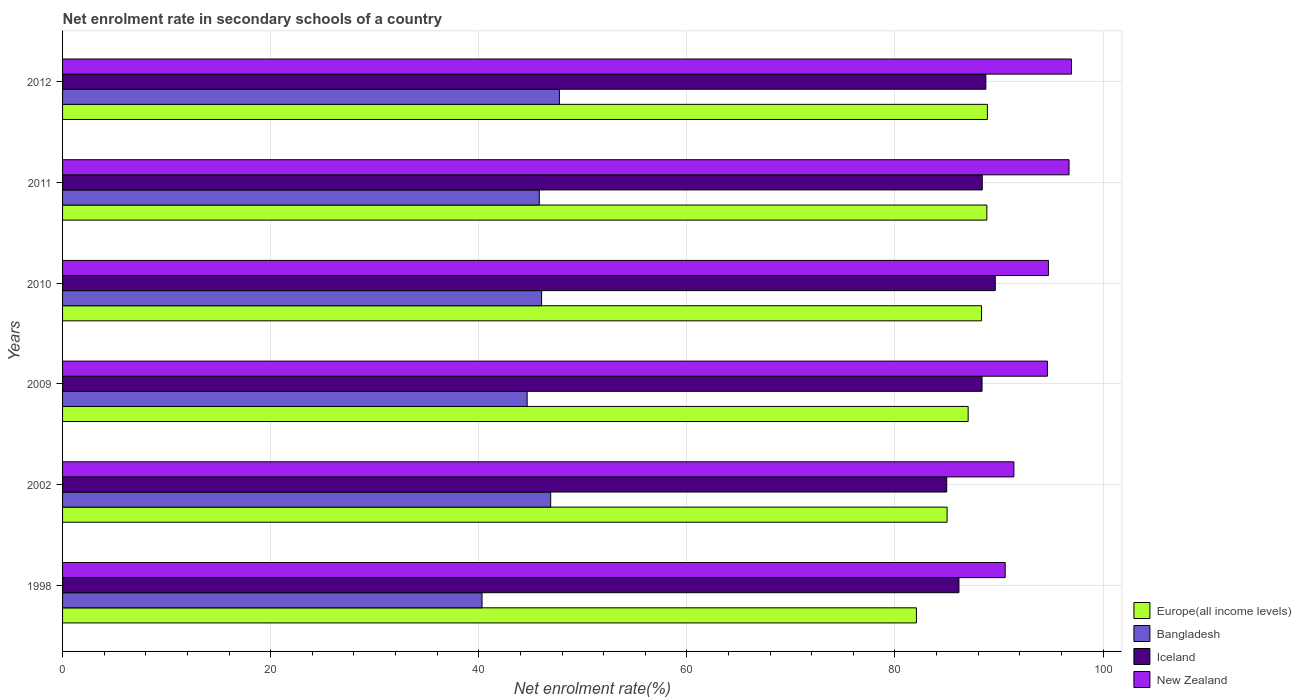How many different coloured bars are there?
Ensure brevity in your answer.  4. Are the number of bars per tick equal to the number of legend labels?
Keep it short and to the point. Yes. How many bars are there on the 2nd tick from the top?
Keep it short and to the point. 4. How many bars are there on the 5th tick from the bottom?
Offer a very short reply. 4. What is the label of the 5th group of bars from the top?
Your response must be concise. 2002. What is the net enrolment rate in secondary schools in Europe(all income levels) in 2010?
Offer a terse response. 88.32. Across all years, what is the maximum net enrolment rate in secondary schools in Bangladesh?
Give a very brief answer. 47.75. Across all years, what is the minimum net enrolment rate in secondary schools in Europe(all income levels)?
Give a very brief answer. 82.06. In which year was the net enrolment rate in secondary schools in Bangladesh maximum?
Your answer should be compact. 2012. In which year was the net enrolment rate in secondary schools in Bangladesh minimum?
Make the answer very short. 1998. What is the total net enrolment rate in secondary schools in New Zealand in the graph?
Make the answer very short. 565.1. What is the difference between the net enrolment rate in secondary schools in Bangladesh in 2009 and that in 2012?
Make the answer very short. -3.1. What is the difference between the net enrolment rate in secondary schools in New Zealand in 2011 and the net enrolment rate in secondary schools in Europe(all income levels) in 1998?
Give a very brief answer. 14.67. What is the average net enrolment rate in secondary schools in Iceland per year?
Your answer should be very brief. 87.71. In the year 2011, what is the difference between the net enrolment rate in secondary schools in New Zealand and net enrolment rate in secondary schools in Europe(all income levels)?
Keep it short and to the point. 7.9. In how many years, is the net enrolment rate in secondary schools in Iceland greater than 84 %?
Offer a very short reply. 6. What is the ratio of the net enrolment rate in secondary schools in Bangladesh in 2009 to that in 2010?
Make the answer very short. 0.97. Is the net enrolment rate in secondary schools in New Zealand in 1998 less than that in 2009?
Offer a very short reply. Yes. What is the difference between the highest and the second highest net enrolment rate in secondary schools in New Zealand?
Offer a terse response. 0.23. What is the difference between the highest and the lowest net enrolment rate in secondary schools in Europe(all income levels)?
Your response must be concise. 6.82. Is the sum of the net enrolment rate in secondary schools in Europe(all income levels) in 2009 and 2012 greater than the maximum net enrolment rate in secondary schools in Iceland across all years?
Offer a very short reply. Yes. Is it the case that in every year, the sum of the net enrolment rate in secondary schools in New Zealand and net enrolment rate in secondary schools in Europe(all income levels) is greater than the sum of net enrolment rate in secondary schools in Bangladesh and net enrolment rate in secondary schools in Iceland?
Your response must be concise. No. What does the 3rd bar from the top in 2011 represents?
Keep it short and to the point. Bangladesh. What does the 1st bar from the bottom in 2010 represents?
Provide a succinct answer. Europe(all income levels). How many bars are there?
Make the answer very short. 24. What is the difference between two consecutive major ticks on the X-axis?
Offer a terse response. 20. Does the graph contain any zero values?
Ensure brevity in your answer.  No. Does the graph contain grids?
Your response must be concise. Yes. How many legend labels are there?
Offer a terse response. 4. What is the title of the graph?
Your response must be concise. Net enrolment rate in secondary schools of a country. Does "Slovak Republic" appear as one of the legend labels in the graph?
Give a very brief answer. No. What is the label or title of the X-axis?
Your answer should be very brief. Net enrolment rate(%). What is the label or title of the Y-axis?
Your answer should be very brief. Years. What is the Net enrolment rate(%) of Europe(all income levels) in 1998?
Your answer should be compact. 82.06. What is the Net enrolment rate(%) of Bangladesh in 1998?
Your answer should be very brief. 40.31. What is the Net enrolment rate(%) of Iceland in 1998?
Offer a very short reply. 86.15. What is the Net enrolment rate(%) of New Zealand in 1998?
Offer a terse response. 90.59. What is the Net enrolment rate(%) in Europe(all income levels) in 2002?
Your response must be concise. 85.01. What is the Net enrolment rate(%) in Bangladesh in 2002?
Your answer should be very brief. 46.91. What is the Net enrolment rate(%) of Iceland in 2002?
Offer a terse response. 84.97. What is the Net enrolment rate(%) of New Zealand in 2002?
Your answer should be very brief. 91.43. What is the Net enrolment rate(%) in Europe(all income levels) in 2009?
Your answer should be very brief. 87.03. What is the Net enrolment rate(%) of Bangladesh in 2009?
Ensure brevity in your answer.  44.65. What is the Net enrolment rate(%) in Iceland in 2009?
Offer a terse response. 88.37. What is the Net enrolment rate(%) in New Zealand in 2009?
Keep it short and to the point. 94.65. What is the Net enrolment rate(%) of Europe(all income levels) in 2010?
Your response must be concise. 88.32. What is the Net enrolment rate(%) in Bangladesh in 2010?
Offer a very short reply. 46.04. What is the Net enrolment rate(%) of Iceland in 2010?
Your answer should be very brief. 89.64. What is the Net enrolment rate(%) in New Zealand in 2010?
Offer a very short reply. 94.75. What is the Net enrolment rate(%) in Europe(all income levels) in 2011?
Ensure brevity in your answer.  88.83. What is the Net enrolment rate(%) of Bangladesh in 2011?
Offer a terse response. 45.82. What is the Net enrolment rate(%) of Iceland in 2011?
Provide a short and direct response. 88.39. What is the Net enrolment rate(%) of New Zealand in 2011?
Keep it short and to the point. 96.73. What is the Net enrolment rate(%) in Europe(all income levels) in 2012?
Your response must be concise. 88.88. What is the Net enrolment rate(%) in Bangladesh in 2012?
Give a very brief answer. 47.75. What is the Net enrolment rate(%) of Iceland in 2012?
Your answer should be very brief. 88.73. What is the Net enrolment rate(%) of New Zealand in 2012?
Give a very brief answer. 96.96. Across all years, what is the maximum Net enrolment rate(%) in Europe(all income levels)?
Give a very brief answer. 88.88. Across all years, what is the maximum Net enrolment rate(%) of Bangladesh?
Make the answer very short. 47.75. Across all years, what is the maximum Net enrolment rate(%) of Iceland?
Offer a very short reply. 89.64. Across all years, what is the maximum Net enrolment rate(%) in New Zealand?
Your answer should be compact. 96.96. Across all years, what is the minimum Net enrolment rate(%) of Europe(all income levels)?
Make the answer very short. 82.06. Across all years, what is the minimum Net enrolment rate(%) in Bangladesh?
Your response must be concise. 40.31. Across all years, what is the minimum Net enrolment rate(%) of Iceland?
Offer a terse response. 84.97. Across all years, what is the minimum Net enrolment rate(%) in New Zealand?
Provide a short and direct response. 90.59. What is the total Net enrolment rate(%) in Europe(all income levels) in the graph?
Provide a short and direct response. 520.12. What is the total Net enrolment rate(%) in Bangladesh in the graph?
Make the answer very short. 271.47. What is the total Net enrolment rate(%) of Iceland in the graph?
Your answer should be very brief. 526.24. What is the total Net enrolment rate(%) of New Zealand in the graph?
Ensure brevity in your answer.  565.1. What is the difference between the Net enrolment rate(%) of Europe(all income levels) in 1998 and that in 2002?
Your response must be concise. -2.95. What is the difference between the Net enrolment rate(%) of Bangladesh in 1998 and that in 2002?
Make the answer very short. -6.6. What is the difference between the Net enrolment rate(%) in Iceland in 1998 and that in 2002?
Offer a very short reply. 1.17. What is the difference between the Net enrolment rate(%) of New Zealand in 1998 and that in 2002?
Offer a very short reply. -0.83. What is the difference between the Net enrolment rate(%) in Europe(all income levels) in 1998 and that in 2009?
Your response must be concise. -4.97. What is the difference between the Net enrolment rate(%) in Bangladesh in 1998 and that in 2009?
Keep it short and to the point. -4.34. What is the difference between the Net enrolment rate(%) in Iceland in 1998 and that in 2009?
Your response must be concise. -2.22. What is the difference between the Net enrolment rate(%) of New Zealand in 1998 and that in 2009?
Make the answer very short. -4.06. What is the difference between the Net enrolment rate(%) of Europe(all income levels) in 1998 and that in 2010?
Ensure brevity in your answer.  -6.26. What is the difference between the Net enrolment rate(%) in Bangladesh in 1998 and that in 2010?
Keep it short and to the point. -5.72. What is the difference between the Net enrolment rate(%) of Iceland in 1998 and that in 2010?
Keep it short and to the point. -3.49. What is the difference between the Net enrolment rate(%) in New Zealand in 1998 and that in 2010?
Offer a very short reply. -4.15. What is the difference between the Net enrolment rate(%) in Europe(all income levels) in 1998 and that in 2011?
Provide a succinct answer. -6.77. What is the difference between the Net enrolment rate(%) of Bangladesh in 1998 and that in 2011?
Ensure brevity in your answer.  -5.5. What is the difference between the Net enrolment rate(%) in Iceland in 1998 and that in 2011?
Keep it short and to the point. -2.24. What is the difference between the Net enrolment rate(%) of New Zealand in 1998 and that in 2011?
Provide a succinct answer. -6.14. What is the difference between the Net enrolment rate(%) in Europe(all income levels) in 1998 and that in 2012?
Offer a very short reply. -6.82. What is the difference between the Net enrolment rate(%) of Bangladesh in 1998 and that in 2012?
Your answer should be very brief. -7.44. What is the difference between the Net enrolment rate(%) of Iceland in 1998 and that in 2012?
Offer a very short reply. -2.59. What is the difference between the Net enrolment rate(%) in New Zealand in 1998 and that in 2012?
Keep it short and to the point. -6.37. What is the difference between the Net enrolment rate(%) of Europe(all income levels) in 2002 and that in 2009?
Offer a terse response. -2.02. What is the difference between the Net enrolment rate(%) of Bangladesh in 2002 and that in 2009?
Provide a short and direct response. 2.26. What is the difference between the Net enrolment rate(%) in Iceland in 2002 and that in 2009?
Your answer should be very brief. -3.39. What is the difference between the Net enrolment rate(%) of New Zealand in 2002 and that in 2009?
Offer a terse response. -3.22. What is the difference between the Net enrolment rate(%) in Europe(all income levels) in 2002 and that in 2010?
Provide a short and direct response. -3.31. What is the difference between the Net enrolment rate(%) of Bangladesh in 2002 and that in 2010?
Provide a short and direct response. 0.87. What is the difference between the Net enrolment rate(%) in Iceland in 2002 and that in 2010?
Make the answer very short. -4.67. What is the difference between the Net enrolment rate(%) of New Zealand in 2002 and that in 2010?
Make the answer very short. -3.32. What is the difference between the Net enrolment rate(%) of Europe(all income levels) in 2002 and that in 2011?
Give a very brief answer. -3.82. What is the difference between the Net enrolment rate(%) in Bangladesh in 2002 and that in 2011?
Your response must be concise. 1.09. What is the difference between the Net enrolment rate(%) in Iceland in 2002 and that in 2011?
Your answer should be compact. -3.41. What is the difference between the Net enrolment rate(%) of New Zealand in 2002 and that in 2011?
Provide a succinct answer. -5.3. What is the difference between the Net enrolment rate(%) in Europe(all income levels) in 2002 and that in 2012?
Your answer should be very brief. -3.87. What is the difference between the Net enrolment rate(%) in Bangladesh in 2002 and that in 2012?
Give a very brief answer. -0.84. What is the difference between the Net enrolment rate(%) of Iceland in 2002 and that in 2012?
Make the answer very short. -3.76. What is the difference between the Net enrolment rate(%) in New Zealand in 2002 and that in 2012?
Your answer should be compact. -5.53. What is the difference between the Net enrolment rate(%) of Europe(all income levels) in 2009 and that in 2010?
Offer a very short reply. -1.29. What is the difference between the Net enrolment rate(%) in Bangladesh in 2009 and that in 2010?
Ensure brevity in your answer.  -1.39. What is the difference between the Net enrolment rate(%) in Iceland in 2009 and that in 2010?
Provide a succinct answer. -1.27. What is the difference between the Net enrolment rate(%) in New Zealand in 2009 and that in 2010?
Provide a succinct answer. -0.1. What is the difference between the Net enrolment rate(%) of Europe(all income levels) in 2009 and that in 2011?
Ensure brevity in your answer.  -1.8. What is the difference between the Net enrolment rate(%) in Bangladesh in 2009 and that in 2011?
Give a very brief answer. -1.17. What is the difference between the Net enrolment rate(%) in Iceland in 2009 and that in 2011?
Your answer should be very brief. -0.02. What is the difference between the Net enrolment rate(%) of New Zealand in 2009 and that in 2011?
Keep it short and to the point. -2.08. What is the difference between the Net enrolment rate(%) in Europe(all income levels) in 2009 and that in 2012?
Keep it short and to the point. -1.85. What is the difference between the Net enrolment rate(%) in Bangladesh in 2009 and that in 2012?
Your response must be concise. -3.1. What is the difference between the Net enrolment rate(%) in Iceland in 2009 and that in 2012?
Offer a very short reply. -0.36. What is the difference between the Net enrolment rate(%) in New Zealand in 2009 and that in 2012?
Your response must be concise. -2.31. What is the difference between the Net enrolment rate(%) in Europe(all income levels) in 2010 and that in 2011?
Ensure brevity in your answer.  -0.51. What is the difference between the Net enrolment rate(%) of Bangladesh in 2010 and that in 2011?
Provide a succinct answer. 0.22. What is the difference between the Net enrolment rate(%) in Iceland in 2010 and that in 2011?
Make the answer very short. 1.25. What is the difference between the Net enrolment rate(%) in New Zealand in 2010 and that in 2011?
Keep it short and to the point. -1.98. What is the difference between the Net enrolment rate(%) in Europe(all income levels) in 2010 and that in 2012?
Provide a succinct answer. -0.56. What is the difference between the Net enrolment rate(%) of Bangladesh in 2010 and that in 2012?
Your answer should be compact. -1.71. What is the difference between the Net enrolment rate(%) of Iceland in 2010 and that in 2012?
Your answer should be very brief. 0.91. What is the difference between the Net enrolment rate(%) of New Zealand in 2010 and that in 2012?
Give a very brief answer. -2.21. What is the difference between the Net enrolment rate(%) of Europe(all income levels) in 2011 and that in 2012?
Your answer should be very brief. -0.05. What is the difference between the Net enrolment rate(%) in Bangladesh in 2011 and that in 2012?
Offer a terse response. -1.93. What is the difference between the Net enrolment rate(%) of Iceland in 2011 and that in 2012?
Make the answer very short. -0.35. What is the difference between the Net enrolment rate(%) of New Zealand in 2011 and that in 2012?
Give a very brief answer. -0.23. What is the difference between the Net enrolment rate(%) of Europe(all income levels) in 1998 and the Net enrolment rate(%) of Bangladesh in 2002?
Ensure brevity in your answer.  35.15. What is the difference between the Net enrolment rate(%) in Europe(all income levels) in 1998 and the Net enrolment rate(%) in Iceland in 2002?
Ensure brevity in your answer.  -2.91. What is the difference between the Net enrolment rate(%) in Europe(all income levels) in 1998 and the Net enrolment rate(%) in New Zealand in 2002?
Ensure brevity in your answer.  -9.37. What is the difference between the Net enrolment rate(%) of Bangladesh in 1998 and the Net enrolment rate(%) of Iceland in 2002?
Your answer should be compact. -44.66. What is the difference between the Net enrolment rate(%) in Bangladesh in 1998 and the Net enrolment rate(%) in New Zealand in 2002?
Your answer should be compact. -51.11. What is the difference between the Net enrolment rate(%) of Iceland in 1998 and the Net enrolment rate(%) of New Zealand in 2002?
Give a very brief answer. -5.28. What is the difference between the Net enrolment rate(%) of Europe(all income levels) in 1998 and the Net enrolment rate(%) of Bangladesh in 2009?
Keep it short and to the point. 37.41. What is the difference between the Net enrolment rate(%) in Europe(all income levels) in 1998 and the Net enrolment rate(%) in Iceland in 2009?
Your answer should be very brief. -6.31. What is the difference between the Net enrolment rate(%) of Europe(all income levels) in 1998 and the Net enrolment rate(%) of New Zealand in 2009?
Provide a succinct answer. -12.59. What is the difference between the Net enrolment rate(%) in Bangladesh in 1998 and the Net enrolment rate(%) in Iceland in 2009?
Offer a terse response. -48.05. What is the difference between the Net enrolment rate(%) in Bangladesh in 1998 and the Net enrolment rate(%) in New Zealand in 2009?
Provide a succinct answer. -54.34. What is the difference between the Net enrolment rate(%) in Iceland in 1998 and the Net enrolment rate(%) in New Zealand in 2009?
Give a very brief answer. -8.5. What is the difference between the Net enrolment rate(%) of Europe(all income levels) in 1998 and the Net enrolment rate(%) of Bangladesh in 2010?
Your answer should be compact. 36.02. What is the difference between the Net enrolment rate(%) in Europe(all income levels) in 1998 and the Net enrolment rate(%) in Iceland in 2010?
Give a very brief answer. -7.58. What is the difference between the Net enrolment rate(%) in Europe(all income levels) in 1998 and the Net enrolment rate(%) in New Zealand in 2010?
Offer a very short reply. -12.69. What is the difference between the Net enrolment rate(%) in Bangladesh in 1998 and the Net enrolment rate(%) in Iceland in 2010?
Make the answer very short. -49.33. What is the difference between the Net enrolment rate(%) of Bangladesh in 1998 and the Net enrolment rate(%) of New Zealand in 2010?
Your answer should be compact. -54.43. What is the difference between the Net enrolment rate(%) in Iceland in 1998 and the Net enrolment rate(%) in New Zealand in 2010?
Provide a short and direct response. -8.6. What is the difference between the Net enrolment rate(%) of Europe(all income levels) in 1998 and the Net enrolment rate(%) of Bangladesh in 2011?
Ensure brevity in your answer.  36.24. What is the difference between the Net enrolment rate(%) of Europe(all income levels) in 1998 and the Net enrolment rate(%) of Iceland in 2011?
Offer a very short reply. -6.33. What is the difference between the Net enrolment rate(%) in Europe(all income levels) in 1998 and the Net enrolment rate(%) in New Zealand in 2011?
Ensure brevity in your answer.  -14.67. What is the difference between the Net enrolment rate(%) of Bangladesh in 1998 and the Net enrolment rate(%) of Iceland in 2011?
Give a very brief answer. -48.07. What is the difference between the Net enrolment rate(%) in Bangladesh in 1998 and the Net enrolment rate(%) in New Zealand in 2011?
Provide a succinct answer. -56.42. What is the difference between the Net enrolment rate(%) of Iceland in 1998 and the Net enrolment rate(%) of New Zealand in 2011?
Offer a terse response. -10.58. What is the difference between the Net enrolment rate(%) of Europe(all income levels) in 1998 and the Net enrolment rate(%) of Bangladesh in 2012?
Offer a terse response. 34.31. What is the difference between the Net enrolment rate(%) in Europe(all income levels) in 1998 and the Net enrolment rate(%) in Iceland in 2012?
Make the answer very short. -6.67. What is the difference between the Net enrolment rate(%) in Europe(all income levels) in 1998 and the Net enrolment rate(%) in New Zealand in 2012?
Offer a very short reply. -14.9. What is the difference between the Net enrolment rate(%) in Bangladesh in 1998 and the Net enrolment rate(%) in Iceland in 2012?
Ensure brevity in your answer.  -48.42. What is the difference between the Net enrolment rate(%) in Bangladesh in 1998 and the Net enrolment rate(%) in New Zealand in 2012?
Provide a succinct answer. -56.65. What is the difference between the Net enrolment rate(%) of Iceland in 1998 and the Net enrolment rate(%) of New Zealand in 2012?
Offer a very short reply. -10.81. What is the difference between the Net enrolment rate(%) in Europe(all income levels) in 2002 and the Net enrolment rate(%) in Bangladesh in 2009?
Offer a terse response. 40.36. What is the difference between the Net enrolment rate(%) of Europe(all income levels) in 2002 and the Net enrolment rate(%) of Iceland in 2009?
Your response must be concise. -3.36. What is the difference between the Net enrolment rate(%) in Europe(all income levels) in 2002 and the Net enrolment rate(%) in New Zealand in 2009?
Offer a very short reply. -9.64. What is the difference between the Net enrolment rate(%) in Bangladesh in 2002 and the Net enrolment rate(%) in Iceland in 2009?
Provide a short and direct response. -41.46. What is the difference between the Net enrolment rate(%) of Bangladesh in 2002 and the Net enrolment rate(%) of New Zealand in 2009?
Your response must be concise. -47.74. What is the difference between the Net enrolment rate(%) in Iceland in 2002 and the Net enrolment rate(%) in New Zealand in 2009?
Offer a very short reply. -9.68. What is the difference between the Net enrolment rate(%) in Europe(all income levels) in 2002 and the Net enrolment rate(%) in Bangladesh in 2010?
Your answer should be very brief. 38.97. What is the difference between the Net enrolment rate(%) in Europe(all income levels) in 2002 and the Net enrolment rate(%) in Iceland in 2010?
Offer a very short reply. -4.63. What is the difference between the Net enrolment rate(%) in Europe(all income levels) in 2002 and the Net enrolment rate(%) in New Zealand in 2010?
Ensure brevity in your answer.  -9.74. What is the difference between the Net enrolment rate(%) of Bangladesh in 2002 and the Net enrolment rate(%) of Iceland in 2010?
Your response must be concise. -42.73. What is the difference between the Net enrolment rate(%) of Bangladesh in 2002 and the Net enrolment rate(%) of New Zealand in 2010?
Your response must be concise. -47.84. What is the difference between the Net enrolment rate(%) of Iceland in 2002 and the Net enrolment rate(%) of New Zealand in 2010?
Give a very brief answer. -9.77. What is the difference between the Net enrolment rate(%) of Europe(all income levels) in 2002 and the Net enrolment rate(%) of Bangladesh in 2011?
Provide a succinct answer. 39.19. What is the difference between the Net enrolment rate(%) in Europe(all income levels) in 2002 and the Net enrolment rate(%) in Iceland in 2011?
Give a very brief answer. -3.38. What is the difference between the Net enrolment rate(%) in Europe(all income levels) in 2002 and the Net enrolment rate(%) in New Zealand in 2011?
Your response must be concise. -11.72. What is the difference between the Net enrolment rate(%) of Bangladesh in 2002 and the Net enrolment rate(%) of Iceland in 2011?
Make the answer very short. -41.48. What is the difference between the Net enrolment rate(%) of Bangladesh in 2002 and the Net enrolment rate(%) of New Zealand in 2011?
Provide a succinct answer. -49.82. What is the difference between the Net enrolment rate(%) in Iceland in 2002 and the Net enrolment rate(%) in New Zealand in 2011?
Give a very brief answer. -11.76. What is the difference between the Net enrolment rate(%) in Europe(all income levels) in 2002 and the Net enrolment rate(%) in Bangladesh in 2012?
Ensure brevity in your answer.  37.26. What is the difference between the Net enrolment rate(%) in Europe(all income levels) in 2002 and the Net enrolment rate(%) in Iceland in 2012?
Your answer should be very brief. -3.72. What is the difference between the Net enrolment rate(%) in Europe(all income levels) in 2002 and the Net enrolment rate(%) in New Zealand in 2012?
Your answer should be very brief. -11.95. What is the difference between the Net enrolment rate(%) in Bangladesh in 2002 and the Net enrolment rate(%) in Iceland in 2012?
Provide a succinct answer. -41.82. What is the difference between the Net enrolment rate(%) of Bangladesh in 2002 and the Net enrolment rate(%) of New Zealand in 2012?
Ensure brevity in your answer.  -50.05. What is the difference between the Net enrolment rate(%) of Iceland in 2002 and the Net enrolment rate(%) of New Zealand in 2012?
Offer a very short reply. -11.99. What is the difference between the Net enrolment rate(%) in Europe(all income levels) in 2009 and the Net enrolment rate(%) in Bangladesh in 2010?
Make the answer very short. 40.99. What is the difference between the Net enrolment rate(%) in Europe(all income levels) in 2009 and the Net enrolment rate(%) in Iceland in 2010?
Your answer should be compact. -2.61. What is the difference between the Net enrolment rate(%) in Europe(all income levels) in 2009 and the Net enrolment rate(%) in New Zealand in 2010?
Provide a succinct answer. -7.71. What is the difference between the Net enrolment rate(%) in Bangladesh in 2009 and the Net enrolment rate(%) in Iceland in 2010?
Offer a very short reply. -44.99. What is the difference between the Net enrolment rate(%) in Bangladesh in 2009 and the Net enrolment rate(%) in New Zealand in 2010?
Provide a short and direct response. -50.1. What is the difference between the Net enrolment rate(%) of Iceland in 2009 and the Net enrolment rate(%) of New Zealand in 2010?
Ensure brevity in your answer.  -6.38. What is the difference between the Net enrolment rate(%) in Europe(all income levels) in 2009 and the Net enrolment rate(%) in Bangladesh in 2011?
Offer a terse response. 41.22. What is the difference between the Net enrolment rate(%) of Europe(all income levels) in 2009 and the Net enrolment rate(%) of Iceland in 2011?
Provide a succinct answer. -1.35. What is the difference between the Net enrolment rate(%) of Europe(all income levels) in 2009 and the Net enrolment rate(%) of New Zealand in 2011?
Your answer should be compact. -9.7. What is the difference between the Net enrolment rate(%) in Bangladesh in 2009 and the Net enrolment rate(%) in Iceland in 2011?
Provide a short and direct response. -43.74. What is the difference between the Net enrolment rate(%) in Bangladesh in 2009 and the Net enrolment rate(%) in New Zealand in 2011?
Your answer should be very brief. -52.08. What is the difference between the Net enrolment rate(%) of Iceland in 2009 and the Net enrolment rate(%) of New Zealand in 2011?
Give a very brief answer. -8.36. What is the difference between the Net enrolment rate(%) in Europe(all income levels) in 2009 and the Net enrolment rate(%) in Bangladesh in 2012?
Offer a very short reply. 39.28. What is the difference between the Net enrolment rate(%) of Europe(all income levels) in 2009 and the Net enrolment rate(%) of Iceland in 2012?
Your answer should be very brief. -1.7. What is the difference between the Net enrolment rate(%) of Europe(all income levels) in 2009 and the Net enrolment rate(%) of New Zealand in 2012?
Provide a short and direct response. -9.93. What is the difference between the Net enrolment rate(%) of Bangladesh in 2009 and the Net enrolment rate(%) of Iceland in 2012?
Ensure brevity in your answer.  -44.08. What is the difference between the Net enrolment rate(%) in Bangladesh in 2009 and the Net enrolment rate(%) in New Zealand in 2012?
Your response must be concise. -52.31. What is the difference between the Net enrolment rate(%) in Iceland in 2009 and the Net enrolment rate(%) in New Zealand in 2012?
Offer a terse response. -8.59. What is the difference between the Net enrolment rate(%) of Europe(all income levels) in 2010 and the Net enrolment rate(%) of Bangladesh in 2011?
Your response must be concise. 42.5. What is the difference between the Net enrolment rate(%) of Europe(all income levels) in 2010 and the Net enrolment rate(%) of Iceland in 2011?
Your response must be concise. -0.07. What is the difference between the Net enrolment rate(%) in Europe(all income levels) in 2010 and the Net enrolment rate(%) in New Zealand in 2011?
Your answer should be very brief. -8.41. What is the difference between the Net enrolment rate(%) in Bangladesh in 2010 and the Net enrolment rate(%) in Iceland in 2011?
Keep it short and to the point. -42.35. What is the difference between the Net enrolment rate(%) in Bangladesh in 2010 and the Net enrolment rate(%) in New Zealand in 2011?
Your response must be concise. -50.69. What is the difference between the Net enrolment rate(%) of Iceland in 2010 and the Net enrolment rate(%) of New Zealand in 2011?
Ensure brevity in your answer.  -7.09. What is the difference between the Net enrolment rate(%) in Europe(all income levels) in 2010 and the Net enrolment rate(%) in Bangladesh in 2012?
Provide a succinct answer. 40.57. What is the difference between the Net enrolment rate(%) in Europe(all income levels) in 2010 and the Net enrolment rate(%) in Iceland in 2012?
Your answer should be very brief. -0.41. What is the difference between the Net enrolment rate(%) in Europe(all income levels) in 2010 and the Net enrolment rate(%) in New Zealand in 2012?
Provide a short and direct response. -8.64. What is the difference between the Net enrolment rate(%) of Bangladesh in 2010 and the Net enrolment rate(%) of Iceland in 2012?
Provide a short and direct response. -42.69. What is the difference between the Net enrolment rate(%) of Bangladesh in 2010 and the Net enrolment rate(%) of New Zealand in 2012?
Make the answer very short. -50.92. What is the difference between the Net enrolment rate(%) of Iceland in 2010 and the Net enrolment rate(%) of New Zealand in 2012?
Make the answer very short. -7.32. What is the difference between the Net enrolment rate(%) of Europe(all income levels) in 2011 and the Net enrolment rate(%) of Bangladesh in 2012?
Offer a terse response. 41.08. What is the difference between the Net enrolment rate(%) in Europe(all income levels) in 2011 and the Net enrolment rate(%) in Iceland in 2012?
Give a very brief answer. 0.1. What is the difference between the Net enrolment rate(%) in Europe(all income levels) in 2011 and the Net enrolment rate(%) in New Zealand in 2012?
Make the answer very short. -8.13. What is the difference between the Net enrolment rate(%) in Bangladesh in 2011 and the Net enrolment rate(%) in Iceland in 2012?
Your answer should be compact. -42.92. What is the difference between the Net enrolment rate(%) in Bangladesh in 2011 and the Net enrolment rate(%) in New Zealand in 2012?
Your answer should be compact. -51.14. What is the difference between the Net enrolment rate(%) in Iceland in 2011 and the Net enrolment rate(%) in New Zealand in 2012?
Your answer should be compact. -8.57. What is the average Net enrolment rate(%) in Europe(all income levels) per year?
Your answer should be compact. 86.69. What is the average Net enrolment rate(%) in Bangladesh per year?
Your answer should be compact. 45.25. What is the average Net enrolment rate(%) in Iceland per year?
Make the answer very short. 87.71. What is the average Net enrolment rate(%) in New Zealand per year?
Keep it short and to the point. 94.18. In the year 1998, what is the difference between the Net enrolment rate(%) of Europe(all income levels) and Net enrolment rate(%) of Bangladesh?
Provide a short and direct response. 41.75. In the year 1998, what is the difference between the Net enrolment rate(%) in Europe(all income levels) and Net enrolment rate(%) in Iceland?
Your answer should be compact. -4.09. In the year 1998, what is the difference between the Net enrolment rate(%) of Europe(all income levels) and Net enrolment rate(%) of New Zealand?
Make the answer very short. -8.53. In the year 1998, what is the difference between the Net enrolment rate(%) in Bangladesh and Net enrolment rate(%) in Iceland?
Make the answer very short. -45.83. In the year 1998, what is the difference between the Net enrolment rate(%) of Bangladesh and Net enrolment rate(%) of New Zealand?
Your answer should be compact. -50.28. In the year 1998, what is the difference between the Net enrolment rate(%) of Iceland and Net enrolment rate(%) of New Zealand?
Keep it short and to the point. -4.45. In the year 2002, what is the difference between the Net enrolment rate(%) of Europe(all income levels) and Net enrolment rate(%) of Bangladesh?
Offer a terse response. 38.1. In the year 2002, what is the difference between the Net enrolment rate(%) of Europe(all income levels) and Net enrolment rate(%) of Iceland?
Your response must be concise. 0.04. In the year 2002, what is the difference between the Net enrolment rate(%) in Europe(all income levels) and Net enrolment rate(%) in New Zealand?
Your answer should be very brief. -6.42. In the year 2002, what is the difference between the Net enrolment rate(%) in Bangladesh and Net enrolment rate(%) in Iceland?
Provide a succinct answer. -38.06. In the year 2002, what is the difference between the Net enrolment rate(%) in Bangladesh and Net enrolment rate(%) in New Zealand?
Give a very brief answer. -44.52. In the year 2002, what is the difference between the Net enrolment rate(%) in Iceland and Net enrolment rate(%) in New Zealand?
Provide a succinct answer. -6.45. In the year 2009, what is the difference between the Net enrolment rate(%) in Europe(all income levels) and Net enrolment rate(%) in Bangladesh?
Provide a short and direct response. 42.38. In the year 2009, what is the difference between the Net enrolment rate(%) of Europe(all income levels) and Net enrolment rate(%) of Iceland?
Give a very brief answer. -1.34. In the year 2009, what is the difference between the Net enrolment rate(%) in Europe(all income levels) and Net enrolment rate(%) in New Zealand?
Your answer should be compact. -7.62. In the year 2009, what is the difference between the Net enrolment rate(%) in Bangladesh and Net enrolment rate(%) in Iceland?
Your answer should be very brief. -43.72. In the year 2009, what is the difference between the Net enrolment rate(%) in Bangladesh and Net enrolment rate(%) in New Zealand?
Your answer should be compact. -50. In the year 2009, what is the difference between the Net enrolment rate(%) in Iceland and Net enrolment rate(%) in New Zealand?
Your answer should be compact. -6.28. In the year 2010, what is the difference between the Net enrolment rate(%) in Europe(all income levels) and Net enrolment rate(%) in Bangladesh?
Keep it short and to the point. 42.28. In the year 2010, what is the difference between the Net enrolment rate(%) of Europe(all income levels) and Net enrolment rate(%) of Iceland?
Make the answer very short. -1.32. In the year 2010, what is the difference between the Net enrolment rate(%) in Europe(all income levels) and Net enrolment rate(%) in New Zealand?
Your answer should be compact. -6.43. In the year 2010, what is the difference between the Net enrolment rate(%) in Bangladesh and Net enrolment rate(%) in Iceland?
Give a very brief answer. -43.6. In the year 2010, what is the difference between the Net enrolment rate(%) of Bangladesh and Net enrolment rate(%) of New Zealand?
Offer a very short reply. -48.71. In the year 2010, what is the difference between the Net enrolment rate(%) of Iceland and Net enrolment rate(%) of New Zealand?
Provide a short and direct response. -5.11. In the year 2011, what is the difference between the Net enrolment rate(%) of Europe(all income levels) and Net enrolment rate(%) of Bangladesh?
Make the answer very short. 43.01. In the year 2011, what is the difference between the Net enrolment rate(%) of Europe(all income levels) and Net enrolment rate(%) of Iceland?
Offer a very short reply. 0.44. In the year 2011, what is the difference between the Net enrolment rate(%) in Europe(all income levels) and Net enrolment rate(%) in New Zealand?
Provide a succinct answer. -7.9. In the year 2011, what is the difference between the Net enrolment rate(%) of Bangladesh and Net enrolment rate(%) of Iceland?
Keep it short and to the point. -42.57. In the year 2011, what is the difference between the Net enrolment rate(%) of Bangladesh and Net enrolment rate(%) of New Zealand?
Ensure brevity in your answer.  -50.91. In the year 2011, what is the difference between the Net enrolment rate(%) in Iceland and Net enrolment rate(%) in New Zealand?
Make the answer very short. -8.34. In the year 2012, what is the difference between the Net enrolment rate(%) of Europe(all income levels) and Net enrolment rate(%) of Bangladesh?
Your response must be concise. 41.13. In the year 2012, what is the difference between the Net enrolment rate(%) of Europe(all income levels) and Net enrolment rate(%) of Iceland?
Your answer should be very brief. 0.15. In the year 2012, what is the difference between the Net enrolment rate(%) of Europe(all income levels) and Net enrolment rate(%) of New Zealand?
Keep it short and to the point. -8.08. In the year 2012, what is the difference between the Net enrolment rate(%) of Bangladesh and Net enrolment rate(%) of Iceland?
Keep it short and to the point. -40.98. In the year 2012, what is the difference between the Net enrolment rate(%) in Bangladesh and Net enrolment rate(%) in New Zealand?
Your answer should be compact. -49.21. In the year 2012, what is the difference between the Net enrolment rate(%) in Iceland and Net enrolment rate(%) in New Zealand?
Provide a short and direct response. -8.23. What is the ratio of the Net enrolment rate(%) in Europe(all income levels) in 1998 to that in 2002?
Your answer should be very brief. 0.97. What is the ratio of the Net enrolment rate(%) of Bangladesh in 1998 to that in 2002?
Make the answer very short. 0.86. What is the ratio of the Net enrolment rate(%) of Iceland in 1998 to that in 2002?
Give a very brief answer. 1.01. What is the ratio of the Net enrolment rate(%) of New Zealand in 1998 to that in 2002?
Offer a terse response. 0.99. What is the ratio of the Net enrolment rate(%) of Europe(all income levels) in 1998 to that in 2009?
Your response must be concise. 0.94. What is the ratio of the Net enrolment rate(%) in Bangladesh in 1998 to that in 2009?
Make the answer very short. 0.9. What is the ratio of the Net enrolment rate(%) in Iceland in 1998 to that in 2009?
Make the answer very short. 0.97. What is the ratio of the Net enrolment rate(%) in New Zealand in 1998 to that in 2009?
Ensure brevity in your answer.  0.96. What is the ratio of the Net enrolment rate(%) in Europe(all income levels) in 1998 to that in 2010?
Provide a short and direct response. 0.93. What is the ratio of the Net enrolment rate(%) in Bangladesh in 1998 to that in 2010?
Your answer should be compact. 0.88. What is the ratio of the Net enrolment rate(%) of Iceland in 1998 to that in 2010?
Keep it short and to the point. 0.96. What is the ratio of the Net enrolment rate(%) in New Zealand in 1998 to that in 2010?
Offer a very short reply. 0.96. What is the ratio of the Net enrolment rate(%) in Europe(all income levels) in 1998 to that in 2011?
Give a very brief answer. 0.92. What is the ratio of the Net enrolment rate(%) in Bangladesh in 1998 to that in 2011?
Give a very brief answer. 0.88. What is the ratio of the Net enrolment rate(%) of Iceland in 1998 to that in 2011?
Keep it short and to the point. 0.97. What is the ratio of the Net enrolment rate(%) of New Zealand in 1998 to that in 2011?
Provide a succinct answer. 0.94. What is the ratio of the Net enrolment rate(%) of Europe(all income levels) in 1998 to that in 2012?
Ensure brevity in your answer.  0.92. What is the ratio of the Net enrolment rate(%) in Bangladesh in 1998 to that in 2012?
Your answer should be compact. 0.84. What is the ratio of the Net enrolment rate(%) of Iceland in 1998 to that in 2012?
Your answer should be very brief. 0.97. What is the ratio of the Net enrolment rate(%) in New Zealand in 1998 to that in 2012?
Provide a short and direct response. 0.93. What is the ratio of the Net enrolment rate(%) of Europe(all income levels) in 2002 to that in 2009?
Offer a very short reply. 0.98. What is the ratio of the Net enrolment rate(%) of Bangladesh in 2002 to that in 2009?
Ensure brevity in your answer.  1.05. What is the ratio of the Net enrolment rate(%) of Iceland in 2002 to that in 2009?
Your response must be concise. 0.96. What is the ratio of the Net enrolment rate(%) of New Zealand in 2002 to that in 2009?
Make the answer very short. 0.97. What is the ratio of the Net enrolment rate(%) in Europe(all income levels) in 2002 to that in 2010?
Give a very brief answer. 0.96. What is the ratio of the Net enrolment rate(%) of Iceland in 2002 to that in 2010?
Offer a terse response. 0.95. What is the ratio of the Net enrolment rate(%) of New Zealand in 2002 to that in 2010?
Make the answer very short. 0.96. What is the ratio of the Net enrolment rate(%) in Europe(all income levels) in 2002 to that in 2011?
Offer a terse response. 0.96. What is the ratio of the Net enrolment rate(%) in Bangladesh in 2002 to that in 2011?
Ensure brevity in your answer.  1.02. What is the ratio of the Net enrolment rate(%) in Iceland in 2002 to that in 2011?
Your response must be concise. 0.96. What is the ratio of the Net enrolment rate(%) in New Zealand in 2002 to that in 2011?
Offer a very short reply. 0.95. What is the ratio of the Net enrolment rate(%) of Europe(all income levels) in 2002 to that in 2012?
Make the answer very short. 0.96. What is the ratio of the Net enrolment rate(%) in Bangladesh in 2002 to that in 2012?
Offer a very short reply. 0.98. What is the ratio of the Net enrolment rate(%) of Iceland in 2002 to that in 2012?
Your answer should be very brief. 0.96. What is the ratio of the Net enrolment rate(%) in New Zealand in 2002 to that in 2012?
Provide a succinct answer. 0.94. What is the ratio of the Net enrolment rate(%) in Europe(all income levels) in 2009 to that in 2010?
Your response must be concise. 0.99. What is the ratio of the Net enrolment rate(%) of Bangladesh in 2009 to that in 2010?
Ensure brevity in your answer.  0.97. What is the ratio of the Net enrolment rate(%) of Iceland in 2009 to that in 2010?
Make the answer very short. 0.99. What is the ratio of the Net enrolment rate(%) in Europe(all income levels) in 2009 to that in 2011?
Offer a terse response. 0.98. What is the ratio of the Net enrolment rate(%) of Bangladesh in 2009 to that in 2011?
Provide a short and direct response. 0.97. What is the ratio of the Net enrolment rate(%) of New Zealand in 2009 to that in 2011?
Keep it short and to the point. 0.98. What is the ratio of the Net enrolment rate(%) in Europe(all income levels) in 2009 to that in 2012?
Your answer should be very brief. 0.98. What is the ratio of the Net enrolment rate(%) of Bangladesh in 2009 to that in 2012?
Your response must be concise. 0.94. What is the ratio of the Net enrolment rate(%) in Iceland in 2009 to that in 2012?
Offer a very short reply. 1. What is the ratio of the Net enrolment rate(%) of New Zealand in 2009 to that in 2012?
Provide a short and direct response. 0.98. What is the ratio of the Net enrolment rate(%) of Iceland in 2010 to that in 2011?
Make the answer very short. 1.01. What is the ratio of the Net enrolment rate(%) in New Zealand in 2010 to that in 2011?
Offer a very short reply. 0.98. What is the ratio of the Net enrolment rate(%) of Europe(all income levels) in 2010 to that in 2012?
Your response must be concise. 0.99. What is the ratio of the Net enrolment rate(%) in Bangladesh in 2010 to that in 2012?
Provide a short and direct response. 0.96. What is the ratio of the Net enrolment rate(%) in Iceland in 2010 to that in 2012?
Your answer should be compact. 1.01. What is the ratio of the Net enrolment rate(%) of New Zealand in 2010 to that in 2012?
Ensure brevity in your answer.  0.98. What is the ratio of the Net enrolment rate(%) of Bangladesh in 2011 to that in 2012?
Your answer should be compact. 0.96. What is the ratio of the Net enrolment rate(%) of Iceland in 2011 to that in 2012?
Your answer should be compact. 1. What is the ratio of the Net enrolment rate(%) of New Zealand in 2011 to that in 2012?
Make the answer very short. 1. What is the difference between the highest and the second highest Net enrolment rate(%) in Europe(all income levels)?
Your answer should be compact. 0.05. What is the difference between the highest and the second highest Net enrolment rate(%) of Bangladesh?
Your answer should be compact. 0.84. What is the difference between the highest and the second highest Net enrolment rate(%) in Iceland?
Offer a terse response. 0.91. What is the difference between the highest and the second highest Net enrolment rate(%) in New Zealand?
Your response must be concise. 0.23. What is the difference between the highest and the lowest Net enrolment rate(%) in Europe(all income levels)?
Keep it short and to the point. 6.82. What is the difference between the highest and the lowest Net enrolment rate(%) of Bangladesh?
Provide a succinct answer. 7.44. What is the difference between the highest and the lowest Net enrolment rate(%) in Iceland?
Your answer should be compact. 4.67. What is the difference between the highest and the lowest Net enrolment rate(%) in New Zealand?
Provide a short and direct response. 6.37. 